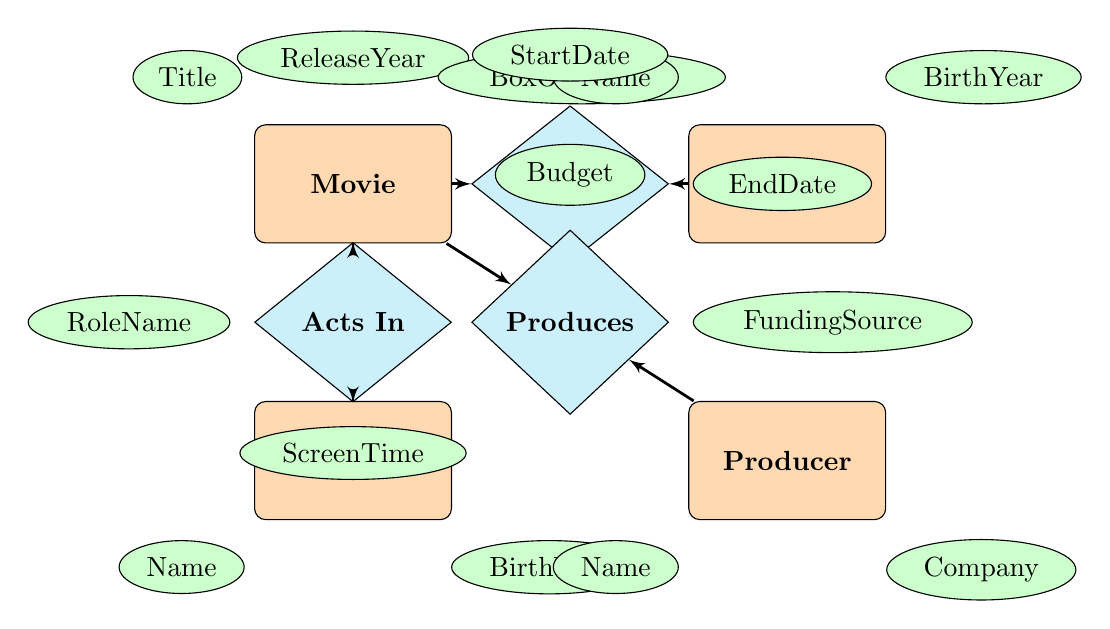What attributes belong to the Movie entity? The attributes for the Movie entity can be found by looking at the entities section of the diagram. They are Title, ReleaseYear, and BoxOfficeGross.
Answer: Title, ReleaseYear, BoxOfficeGross Who is related to the movie in the "Acts In" relationship? The Actor entity is connected to the Movie entity through the "Acts In" relationship, indicating that actors play roles in movies.
Answer: Actor How many relationships are there in the diagram? Counting the lines connecting entities to relationships, there are three relationships shown: Directs, Acts In, and Produces, linking the respective entities to movies.
Answer: 3 What is the value of the attribute "StartDate" in the "Directs" relationship? The "StartDate" is an attribute of the Directs relationship, however, it does not specify a value in the diagram, so based on the visual context, it can be interpreted as a placeholder.
Answer: [no value] How does the relationship between a Producer and a Movie differ from that of a Director and a Movie? The Producer relationship (Produces) focuses on financial aspects like Budget and FundingSource, while the Director relationship (Directs) includes time frames like StartDate and EndDate.
Answer: Financial vs. Time Which entity has attributes related to birth year? Both the Director entity and the Actor entity contain the BirthYear attribute, indicating that information related to their birth years is stored there.
Answer: Director, Actor What does the "RoleName" attribute signify in the Acts In relationship? The "RoleName" attribute under the Acts In relationship specifies the character or role portrayed by an actor in a movie, providing insight into their performance.
Answer: Character or role What is the main purpose of the Produces relationship? The Produces relationship primarily encompasses the responsibilities of a Producer, which pertain to budgeting and funding sources for a movie, emphasizing financial control.
Answer: Financial control How many entities are involved in this diagram? The diagram identifies four distinct entities: Movie, Director, Actor, and Producer, corresponding to various roles within the film industry.
Answer: 4 